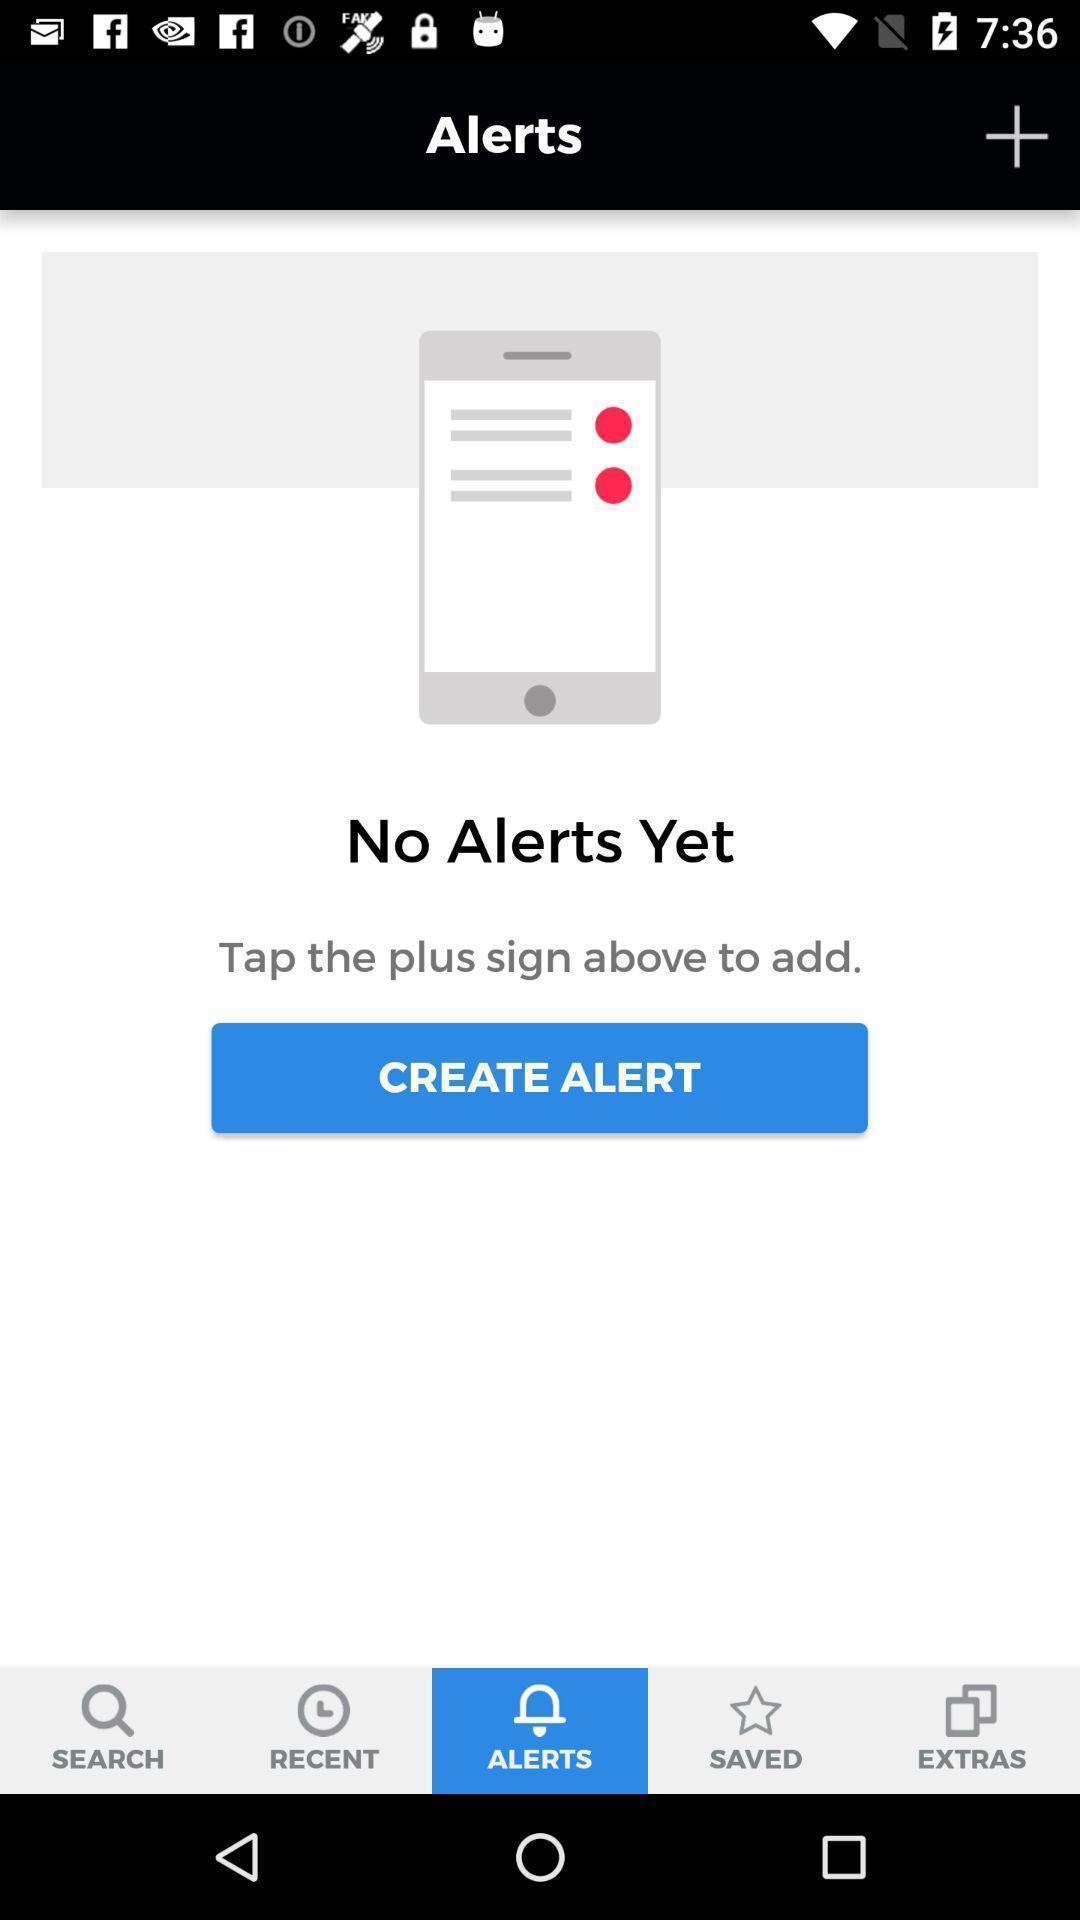Explain the elements present in this screenshot. Page shows to create your alerts. 